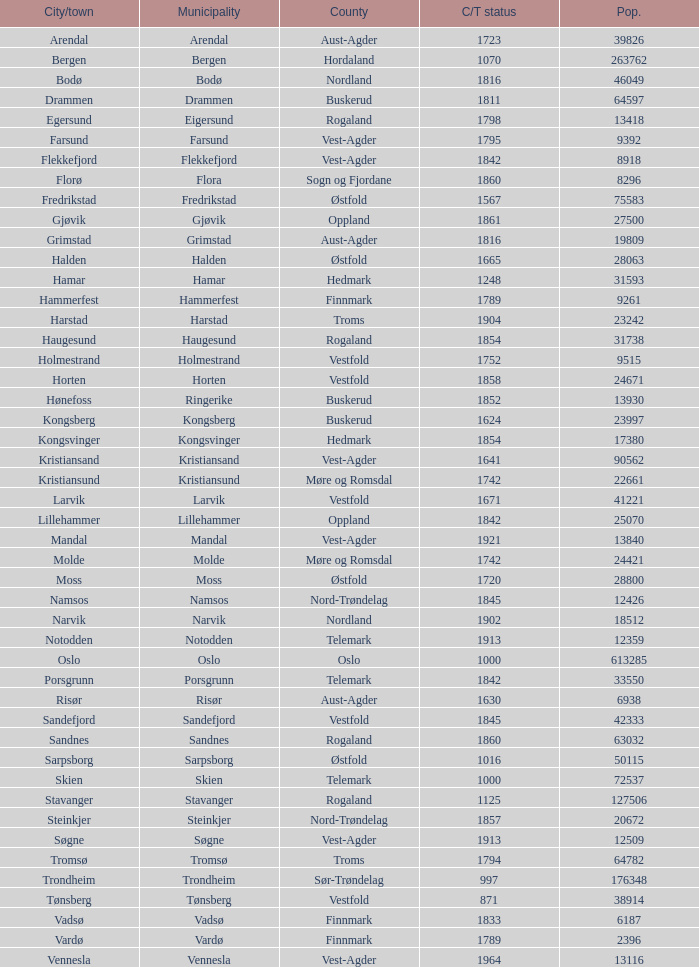What are the cities/towns located in the municipality of Horten? Horten. 